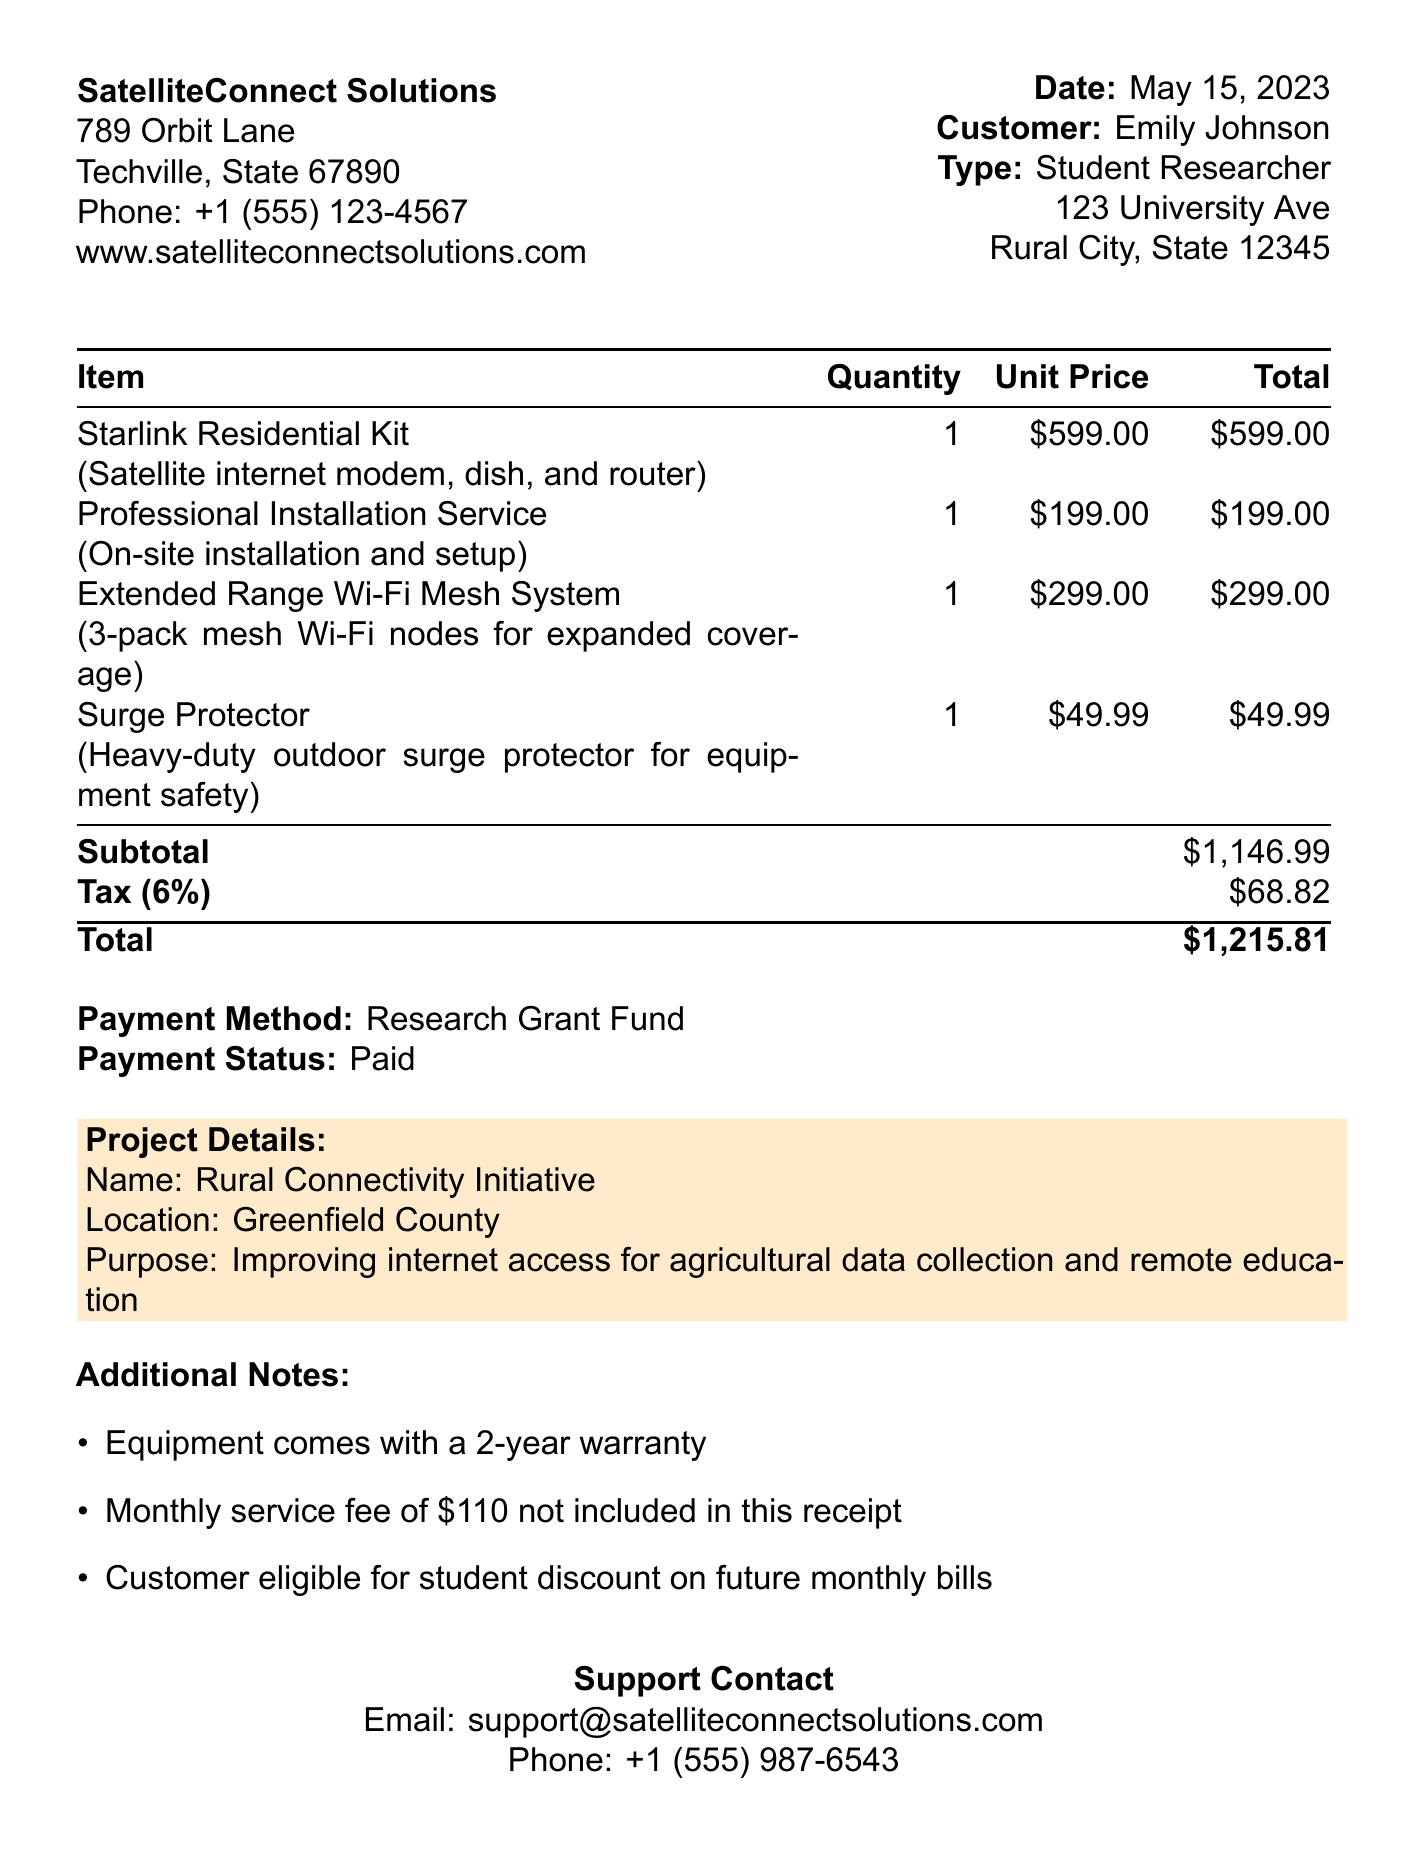What is the receipt number? The receipt number is clearly stated at the top of the document, indicating a unique identifier for this transaction.
Answer: SIM-2023-0542 Who is the customer? The customer is identified in the receipt with name and type details, indicating who made the purchase.
Answer: Emily Johnson What is the total amount paid? The total amount is the final price after tax, indicating what the customer paid for the services and equipment.
Answer: $1215.81 What is the date of the transaction? The date of the transaction is mentioned prominently, providing a reference for when the purchase was made.
Answer: May 15, 2023 How much is the tax rate applied? The tax rate is mentioned in the breakdown of costs, giving insight into how the total was calculated.
Answer: 6% What installation service was included in the purchase? The installation service is detailed in the item list, explaining what additional services were bundled with the modem kit.
Answer: Professional Installation Service What is the purpose of the Rural Connectivity Initiative? The purpose is stated under project details, explaining the goal of the project related to connectivity.
Answer: Improving internet access for agricultural data collection and remote education What is the customer eligible for on future monthly bills? This information is provided in the additional notes section, indicating potential discounts for the customer.
Answer: Student discount What warranty is provided with the equipment? The warranty details are included in the additional notes, indicating the duration of coverage for the products purchased.
Answer: 2-year warranty 